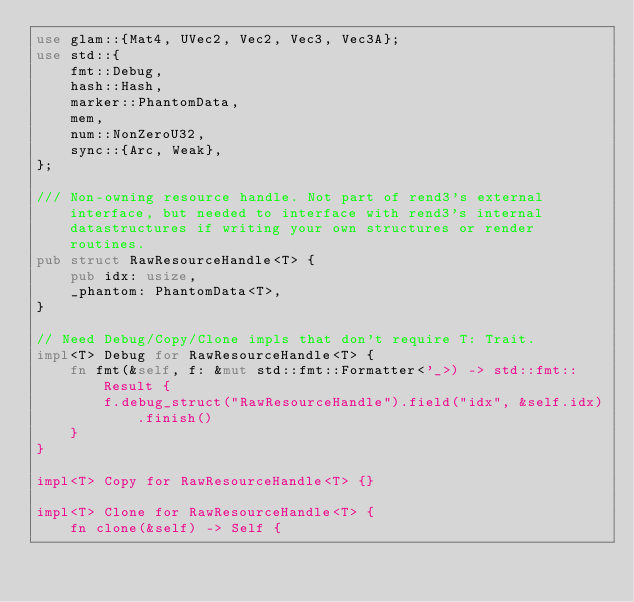<code> <loc_0><loc_0><loc_500><loc_500><_Rust_>use glam::{Mat4, UVec2, Vec2, Vec3, Vec3A};
use std::{
    fmt::Debug,
    hash::Hash,
    marker::PhantomData,
    mem,
    num::NonZeroU32,
    sync::{Arc, Weak},
};

/// Non-owning resource handle. Not part of rend3's external interface, but needed to interface with rend3's internal datastructures if writing your own structures or render routines.
pub struct RawResourceHandle<T> {
    pub idx: usize,
    _phantom: PhantomData<T>,
}

// Need Debug/Copy/Clone impls that don't require T: Trait.
impl<T> Debug for RawResourceHandle<T> {
    fn fmt(&self, f: &mut std::fmt::Formatter<'_>) -> std::fmt::Result {
        f.debug_struct("RawResourceHandle").field("idx", &self.idx).finish()
    }
}

impl<T> Copy for RawResourceHandle<T> {}

impl<T> Clone for RawResourceHandle<T> {
    fn clone(&self) -> Self {</code> 